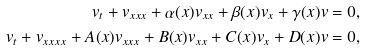Convert formula to latex. <formula><loc_0><loc_0><loc_500><loc_500>v _ { t } + v _ { x x x } + \alpha ( x ) v _ { x x } + \beta ( x ) v _ { x } + \gamma ( x ) v = 0 , \\ v _ { t } + v _ { x x x x } + A ( x ) v _ { x x x } + B ( x ) v _ { x x } + C ( x ) v _ { x } + D ( x ) v = 0 ,</formula> 